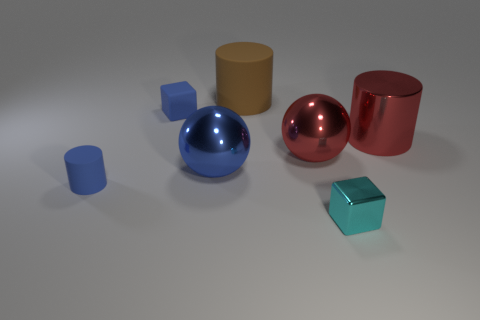Add 3 large red shiny objects. How many objects exist? 10 Subtract all cylinders. How many objects are left? 4 Subtract 0 cyan spheres. How many objects are left? 7 Subtract all spheres. Subtract all tiny cyan things. How many objects are left? 4 Add 4 metallic cylinders. How many metallic cylinders are left? 5 Add 7 small purple rubber blocks. How many small purple rubber blocks exist? 7 